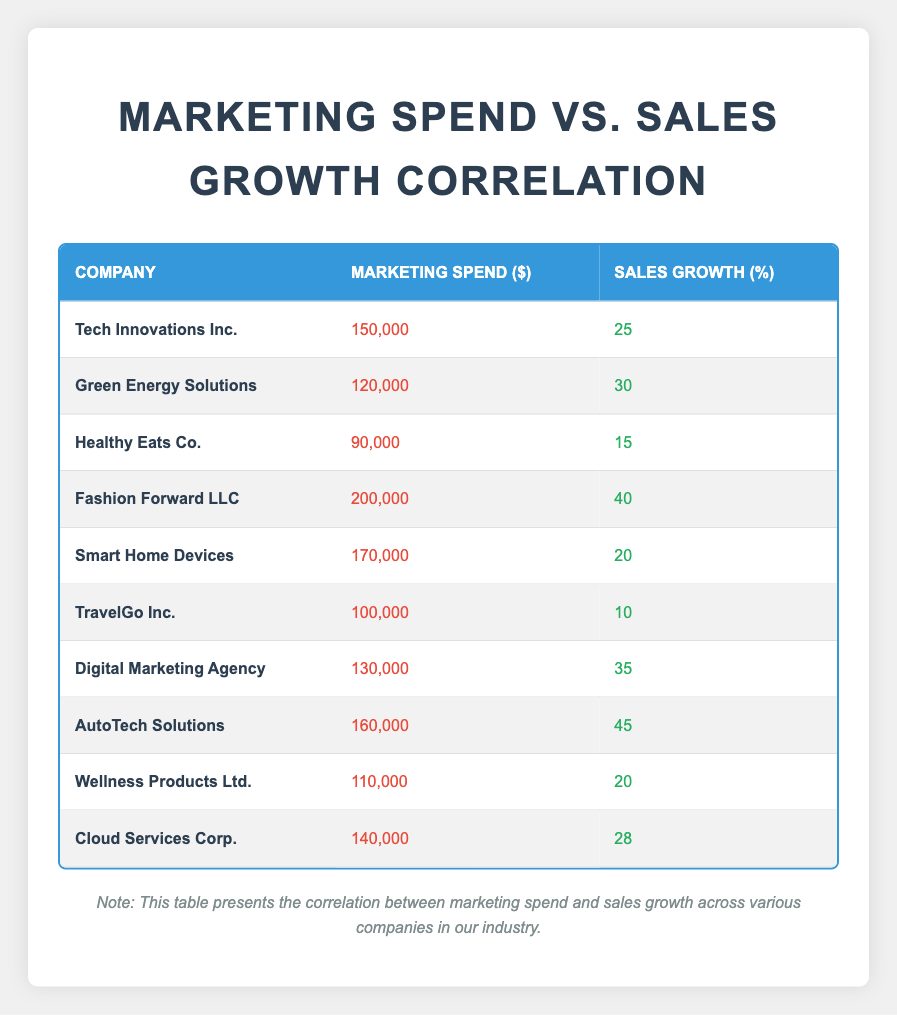What is the marketing spend for AutoTech Solutions? The table indicates that the marketing spend for AutoTech Solutions is listed specifically under the "Marketing Spend" column corresponding to that company. According to the table, it is 160,000.
Answer: 160,000 Which company had the highest sales growth, and what was that figure? By inspecting the "Sales Growth" column, we identify that AutoTech Solutions records the highest sales growth at 45. This is the maximum value present in that column.
Answer: AutoTech Solutions, 45 What is the average marketing spend across all listed companies? To calculate the average marketing spend, we first sum all the marketing spends: 150,000 + 120,000 + 90,000 + 200,000 + 170,000 + 100,000 + 130,000 + 160,000 + 110,000 + 140,000 = 1,370,000. Dividing this sum by the number of companies (10) gives 137,000.
Answer: 137,000 Is the sales growth for Digital Marketing Agency greater than 30? Looking specifically at the "Sales Growth" value for Digital Marketing Agency, which is 35, we see that it is greater than 30. Thus, the statement is confirmed.
Answer: Yes What is the difference between the highest and the lowest sales growth values? The highest sales growth value is for AutoTech Solutions at 45, and the lowest is for TravelGo Inc. at 10. The difference is calculated as 45 - 10 = 35.
Answer: 35 